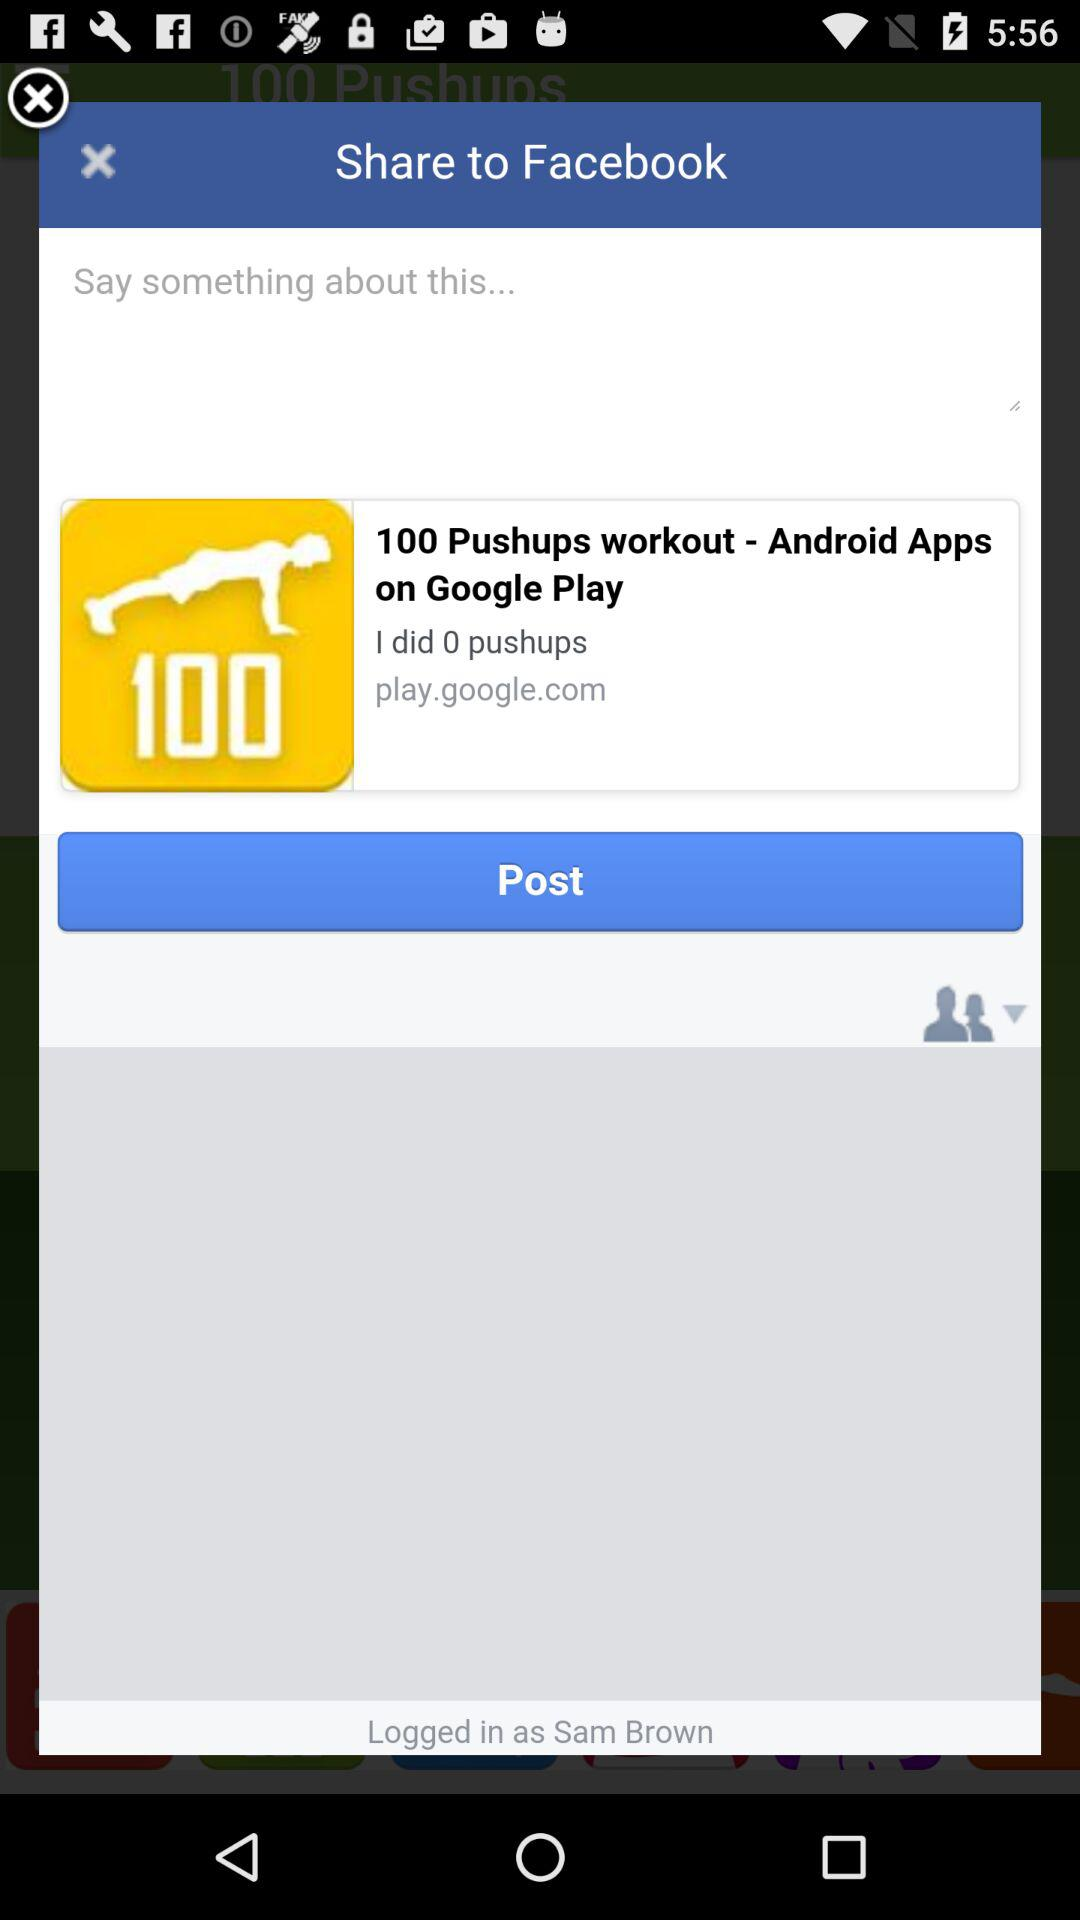What is the name of the application? The names of the applications are "100 Pushups workout" and "Facebook". 